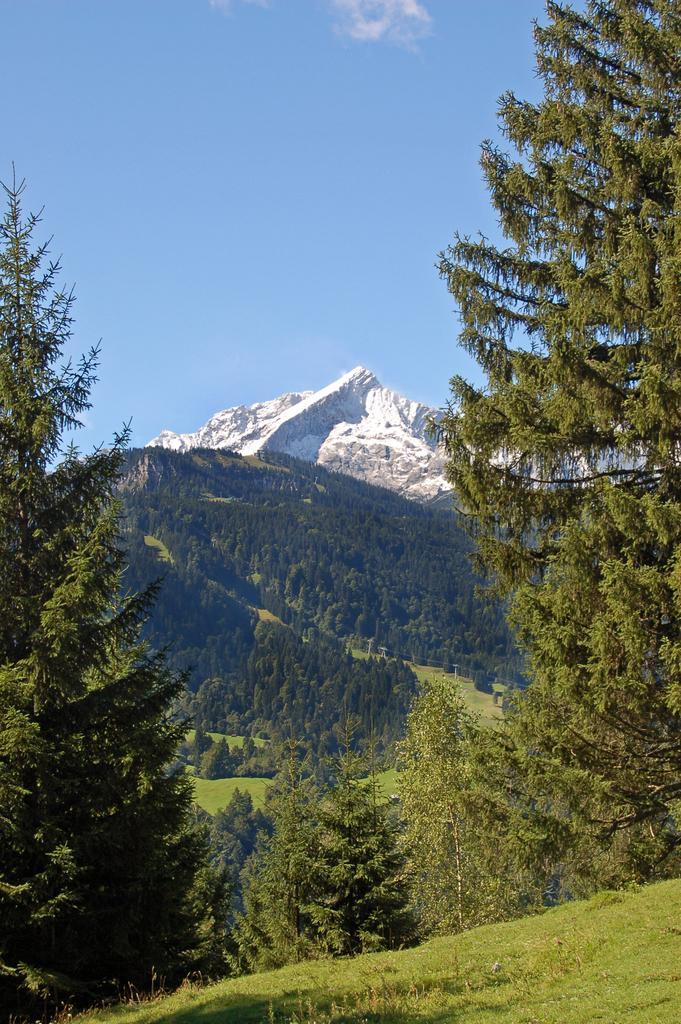Could you give a brief overview of what you see in this image? In this image we can see a group of trees and some grass. On the backside we can see a group of trees on the hill, the ice hill and the sky which looks cloudy. 